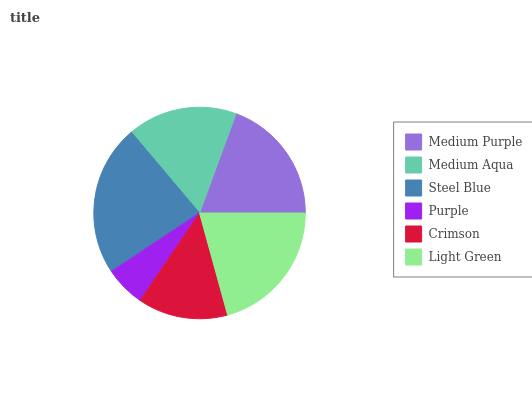Is Purple the minimum?
Answer yes or no. Yes. Is Steel Blue the maximum?
Answer yes or no. Yes. Is Medium Aqua the minimum?
Answer yes or no. No. Is Medium Aqua the maximum?
Answer yes or no. No. Is Medium Purple greater than Medium Aqua?
Answer yes or no. Yes. Is Medium Aqua less than Medium Purple?
Answer yes or no. Yes. Is Medium Aqua greater than Medium Purple?
Answer yes or no. No. Is Medium Purple less than Medium Aqua?
Answer yes or no. No. Is Medium Purple the high median?
Answer yes or no. Yes. Is Medium Aqua the low median?
Answer yes or no. Yes. Is Crimson the high median?
Answer yes or no. No. Is Medium Purple the low median?
Answer yes or no. No. 